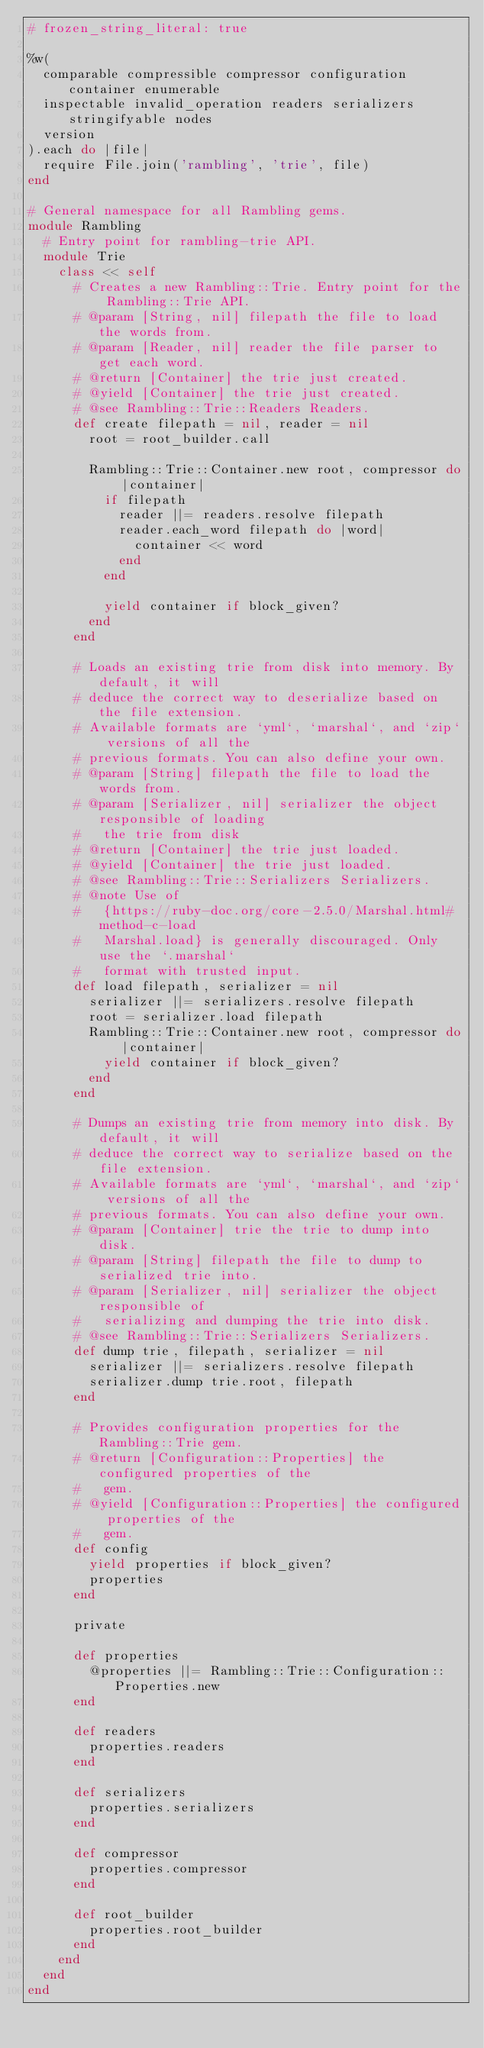Convert code to text. <code><loc_0><loc_0><loc_500><loc_500><_Ruby_># frozen_string_literal: true

%w(
  comparable compressible compressor configuration container enumerable
  inspectable invalid_operation readers serializers stringifyable nodes
  version
).each do |file|
  require File.join('rambling', 'trie', file)
end

# General namespace for all Rambling gems.
module Rambling
  # Entry point for rambling-trie API.
  module Trie
    class << self
      # Creates a new Rambling::Trie. Entry point for the Rambling::Trie API.
      # @param [String, nil] filepath the file to load the words from.
      # @param [Reader, nil] reader the file parser to get each word.
      # @return [Container] the trie just created.
      # @yield [Container] the trie just created.
      # @see Rambling::Trie::Readers Readers.
      def create filepath = nil, reader = nil
        root = root_builder.call

        Rambling::Trie::Container.new root, compressor do |container|
          if filepath
            reader ||= readers.resolve filepath
            reader.each_word filepath do |word|
              container << word
            end
          end

          yield container if block_given?
        end
      end

      # Loads an existing trie from disk into memory. By default, it will
      # deduce the correct way to deserialize based on the file extension.
      # Available formats are `yml`, `marshal`, and `zip` versions of all the
      # previous formats. You can also define your own.
      # @param [String] filepath the file to load the words from.
      # @param [Serializer, nil] serializer the object responsible of loading
      #   the trie from disk
      # @return [Container] the trie just loaded.
      # @yield [Container] the trie just loaded.
      # @see Rambling::Trie::Serializers Serializers.
      # @note Use of
      #   {https://ruby-doc.org/core-2.5.0/Marshal.html#method-c-load
      #   Marshal.load} is generally discouraged. Only use the `.marshal`
      #   format with trusted input.
      def load filepath, serializer = nil
        serializer ||= serializers.resolve filepath
        root = serializer.load filepath
        Rambling::Trie::Container.new root, compressor do |container|
          yield container if block_given?
        end
      end

      # Dumps an existing trie from memory into disk. By default, it will
      # deduce the correct way to serialize based on the file extension.
      # Available formats are `yml`, `marshal`, and `zip` versions of all the
      # previous formats. You can also define your own.
      # @param [Container] trie the trie to dump into disk.
      # @param [String] filepath the file to dump to serialized trie into.
      # @param [Serializer, nil] serializer the object responsible of
      #   serializing and dumping the trie into disk.
      # @see Rambling::Trie::Serializers Serializers.
      def dump trie, filepath, serializer = nil
        serializer ||= serializers.resolve filepath
        serializer.dump trie.root, filepath
      end

      # Provides configuration properties for the Rambling::Trie gem.
      # @return [Configuration::Properties] the configured properties of the
      #   gem.
      # @yield [Configuration::Properties] the configured properties of the
      #   gem.
      def config
        yield properties if block_given?
        properties
      end

      private

      def properties
        @properties ||= Rambling::Trie::Configuration::Properties.new
      end

      def readers
        properties.readers
      end

      def serializers
        properties.serializers
      end

      def compressor
        properties.compressor
      end

      def root_builder
        properties.root_builder
      end
    end
  end
end
</code> 